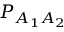Convert formula to latex. <formula><loc_0><loc_0><loc_500><loc_500>P _ { A _ { 1 } A _ { 2 } }</formula> 